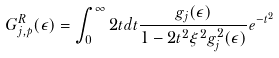<formula> <loc_0><loc_0><loc_500><loc_500>G ^ { R } _ { j , p } ( \epsilon ) = \int _ { 0 } ^ { \infty } 2 t d t \frac { g _ { j } ( \epsilon ) } { 1 - 2 t ^ { 2 } \xi ^ { 2 } g _ { j } ^ { 2 } ( \epsilon ) } e ^ { - t ^ { 2 } }</formula> 